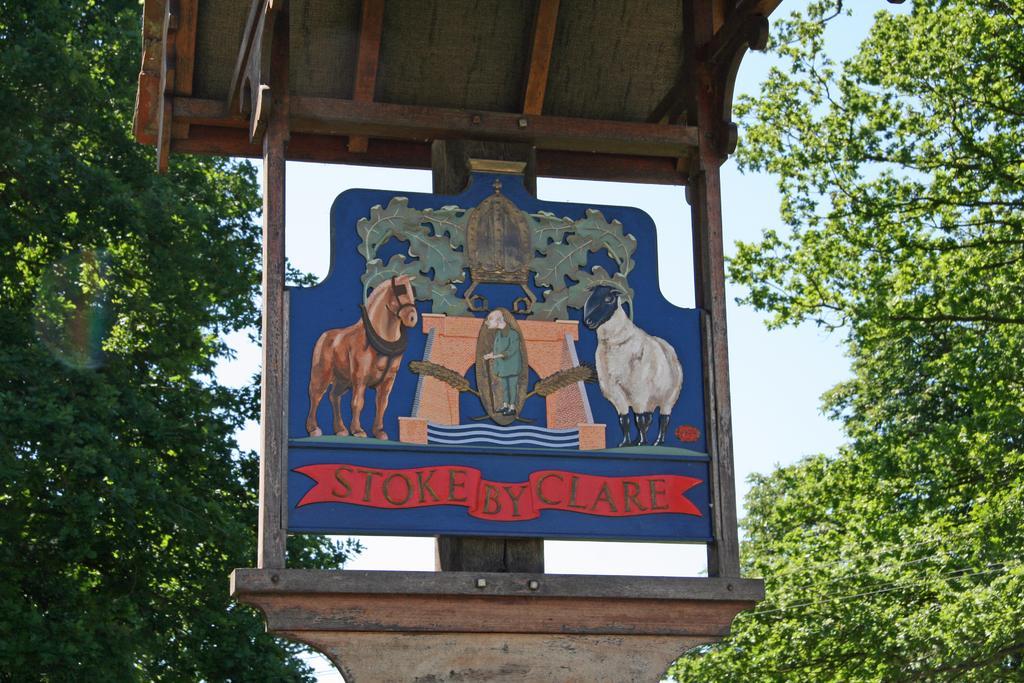Describe this image in one or two sentences. This image is consists of a wooden board. To the left and right there are trees. In the background, there is sky. 